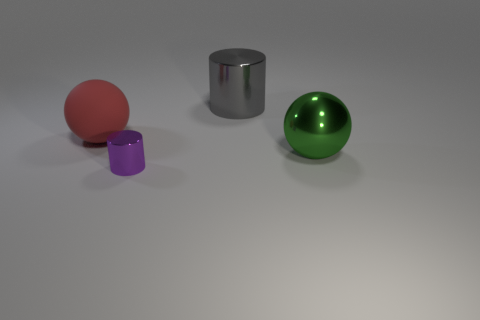Add 4 gray metal cylinders. How many objects exist? 8 Subtract 0 gray spheres. How many objects are left? 4 Subtract all small purple metal objects. Subtract all red things. How many objects are left? 2 Add 1 large things. How many large things are left? 4 Add 4 cylinders. How many cylinders exist? 6 